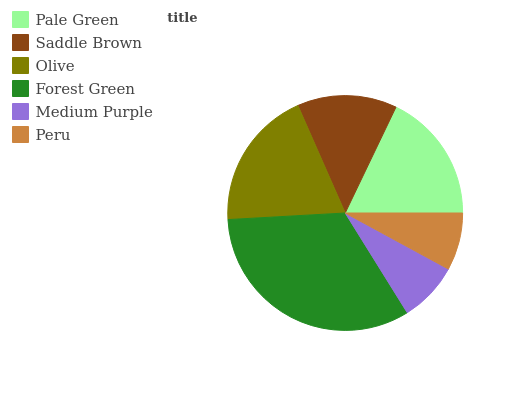Is Peru the minimum?
Answer yes or no. Yes. Is Forest Green the maximum?
Answer yes or no. Yes. Is Saddle Brown the minimum?
Answer yes or no. No. Is Saddle Brown the maximum?
Answer yes or no. No. Is Pale Green greater than Saddle Brown?
Answer yes or no. Yes. Is Saddle Brown less than Pale Green?
Answer yes or no. Yes. Is Saddle Brown greater than Pale Green?
Answer yes or no. No. Is Pale Green less than Saddle Brown?
Answer yes or no. No. Is Pale Green the high median?
Answer yes or no. Yes. Is Saddle Brown the low median?
Answer yes or no. Yes. Is Medium Purple the high median?
Answer yes or no. No. Is Pale Green the low median?
Answer yes or no. No. 